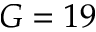<formula> <loc_0><loc_0><loc_500><loc_500>G = 1 9</formula> 